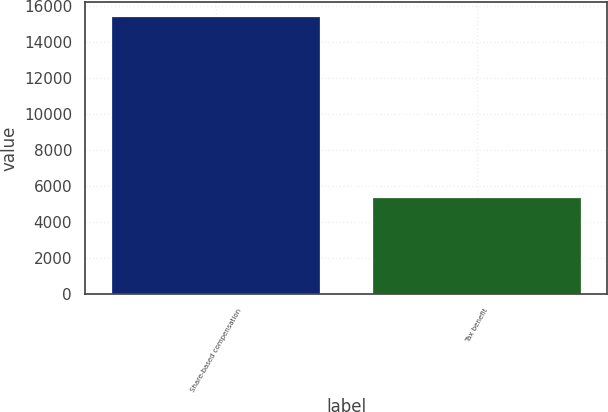<chart> <loc_0><loc_0><loc_500><loc_500><bar_chart><fcel>Share-based compensation<fcel>Tax benefit<nl><fcel>15453<fcel>5408<nl></chart> 